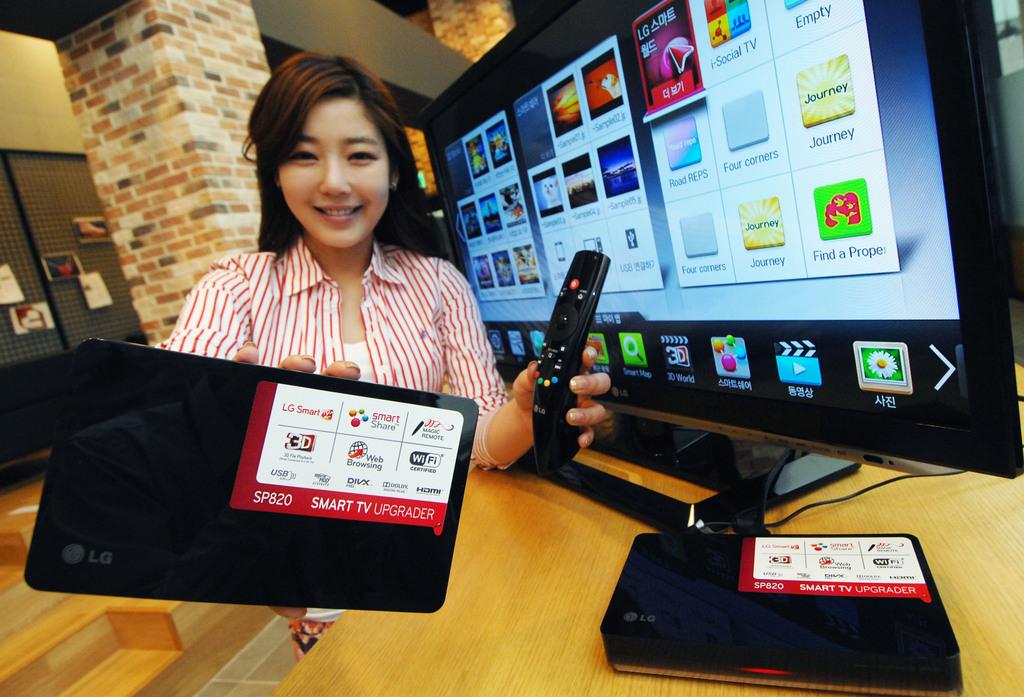What word is right above the green icon on the right?
Give a very brief answer. Journey. 